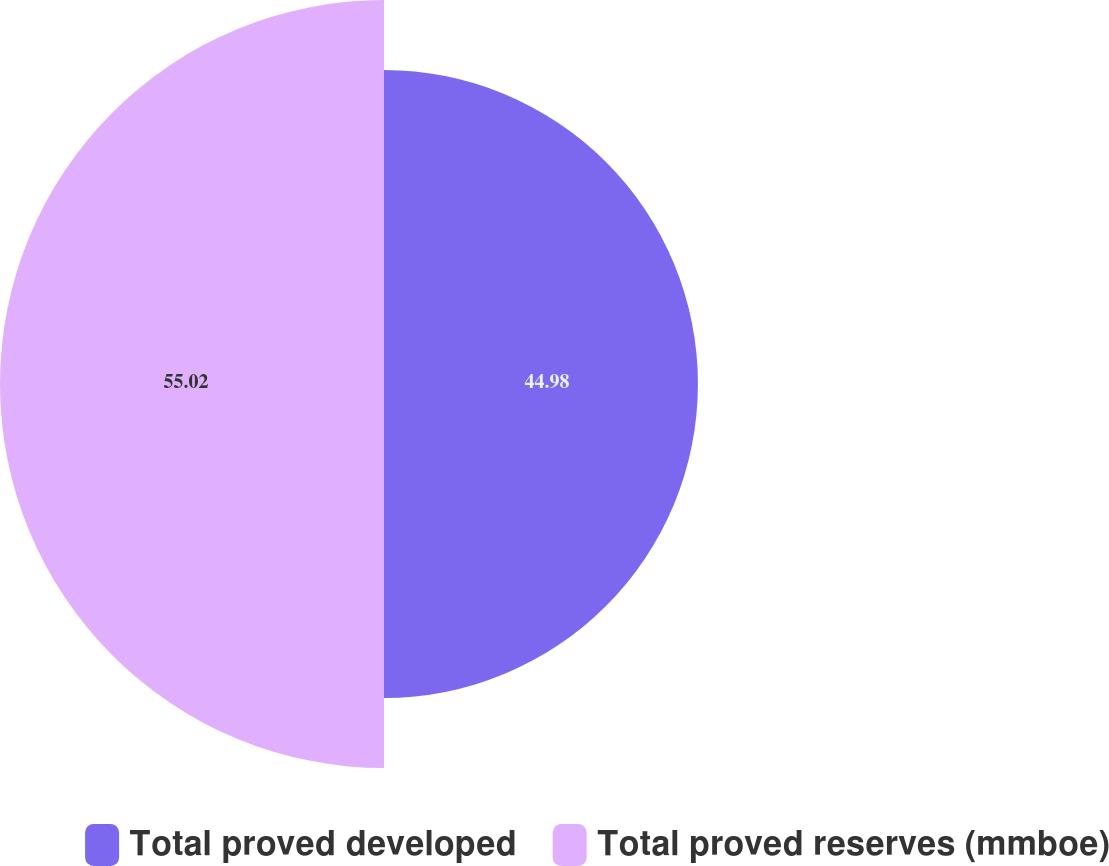Convert chart. <chart><loc_0><loc_0><loc_500><loc_500><pie_chart><fcel>Total proved developed<fcel>Total proved reserves (mmboe)<nl><fcel>44.98%<fcel>55.02%<nl></chart> 